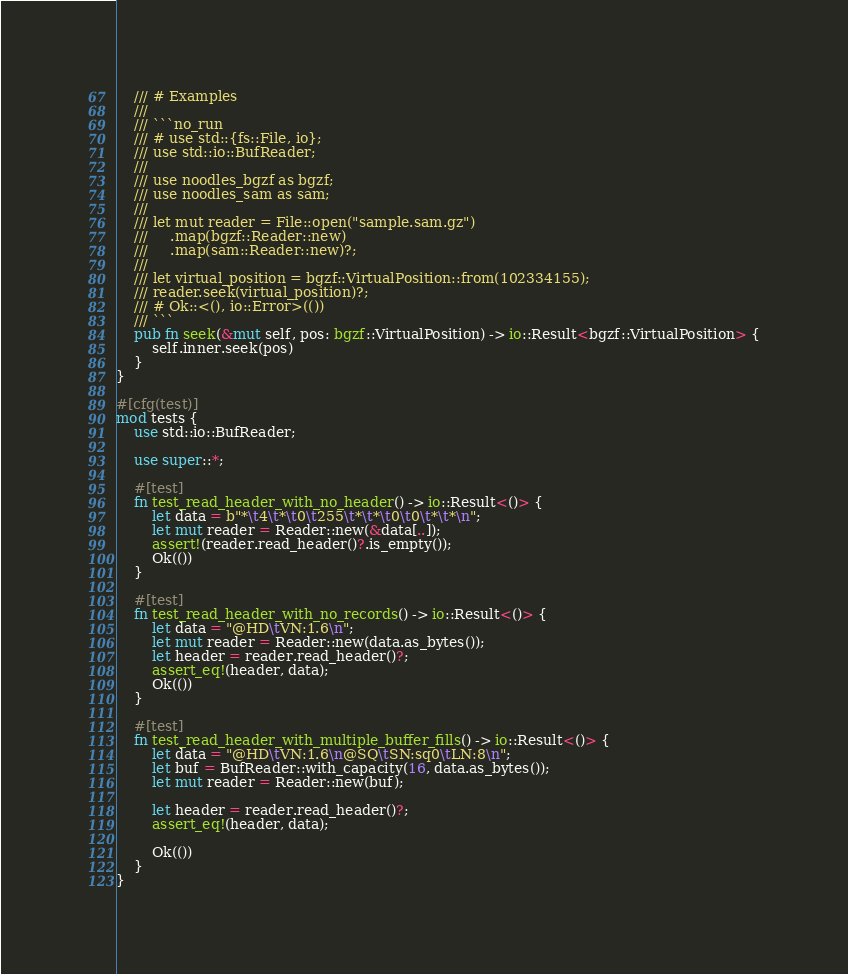Convert code to text. <code><loc_0><loc_0><loc_500><loc_500><_Rust_>    /// # Examples
    ///
    /// ```no_run
    /// # use std::{fs::File, io};
    /// use std::io::BufReader;
    ///
    /// use noodles_bgzf as bgzf;
    /// use noodles_sam as sam;
    ///
    /// let mut reader = File::open("sample.sam.gz")
    ///     .map(bgzf::Reader::new)
    ///     .map(sam::Reader::new)?;
    ///
    /// let virtual_position = bgzf::VirtualPosition::from(102334155);
    /// reader.seek(virtual_position)?;
    /// # Ok::<(), io::Error>(())
    /// ```
    pub fn seek(&mut self, pos: bgzf::VirtualPosition) -> io::Result<bgzf::VirtualPosition> {
        self.inner.seek(pos)
    }
}

#[cfg(test)]
mod tests {
    use std::io::BufReader;

    use super::*;

    #[test]
    fn test_read_header_with_no_header() -> io::Result<()> {
        let data = b"*\t4\t*\t0\t255\t*\t*\t0\t0\t*\t*\n";
        let mut reader = Reader::new(&data[..]);
        assert!(reader.read_header()?.is_empty());
        Ok(())
    }

    #[test]
    fn test_read_header_with_no_records() -> io::Result<()> {
        let data = "@HD\tVN:1.6\n";
        let mut reader = Reader::new(data.as_bytes());
        let header = reader.read_header()?;
        assert_eq!(header, data);
        Ok(())
    }

    #[test]
    fn test_read_header_with_multiple_buffer_fills() -> io::Result<()> {
        let data = "@HD\tVN:1.6\n@SQ\tSN:sq0\tLN:8\n";
        let buf = BufReader::with_capacity(16, data.as_bytes());
        let mut reader = Reader::new(buf);

        let header = reader.read_header()?;
        assert_eq!(header, data);

        Ok(())
    }
}
</code> 